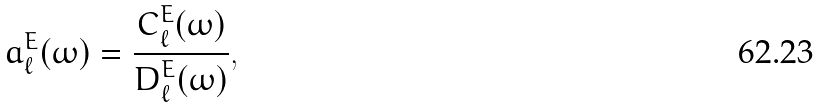Convert formula to latex. <formula><loc_0><loc_0><loc_500><loc_500>a _ { \ell } ^ { E } ( \omega ) = \frac { C ^ { E } _ { \ell } ( \omega ) } { D ^ { E } _ { \ell } ( \omega ) } ,</formula> 